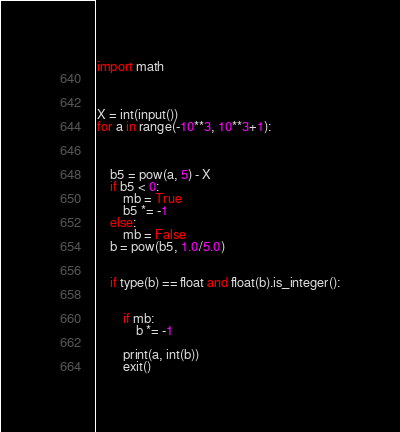<code> <loc_0><loc_0><loc_500><loc_500><_Python_>import math



X = int(input())
for a in range(-10**3, 10**3+1):

   

    b5 = pow(a, 5) - X
    if b5 < 0:
        mb = True
        b5 *= -1
    else:
        mb = False
    b = pow(b5, 1.0/5.0)
    

    if type(b) == float and float(b).is_integer():
 

        if mb:
            b *= -1

        print(a, int(b))
        exit()</code> 